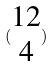<formula> <loc_0><loc_0><loc_500><loc_500>( \begin{matrix} 1 2 \\ 4 \end{matrix} )</formula> 